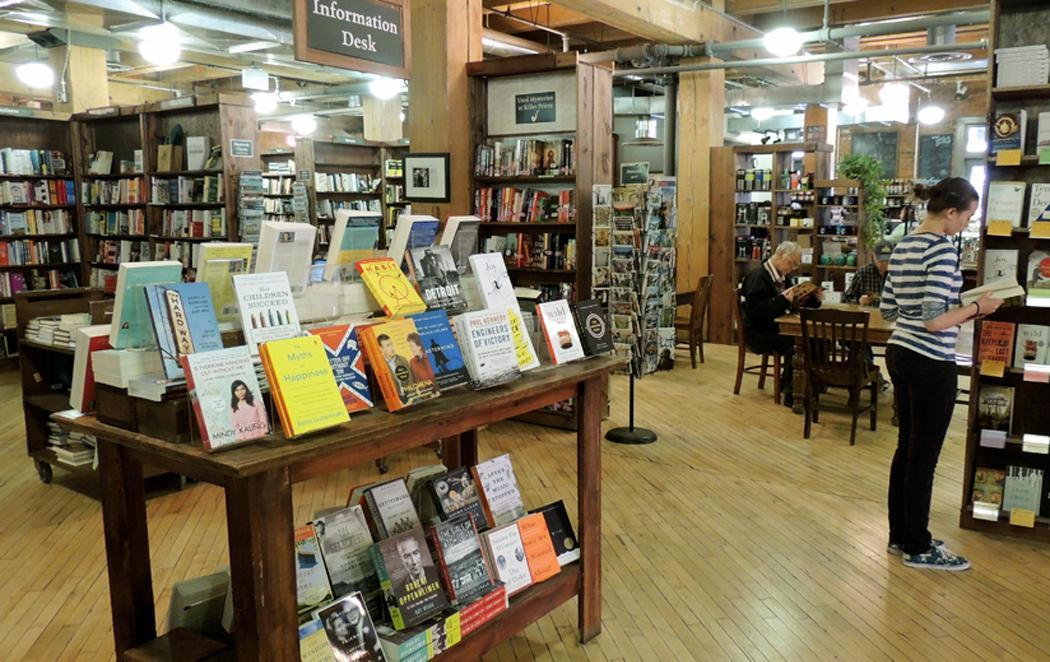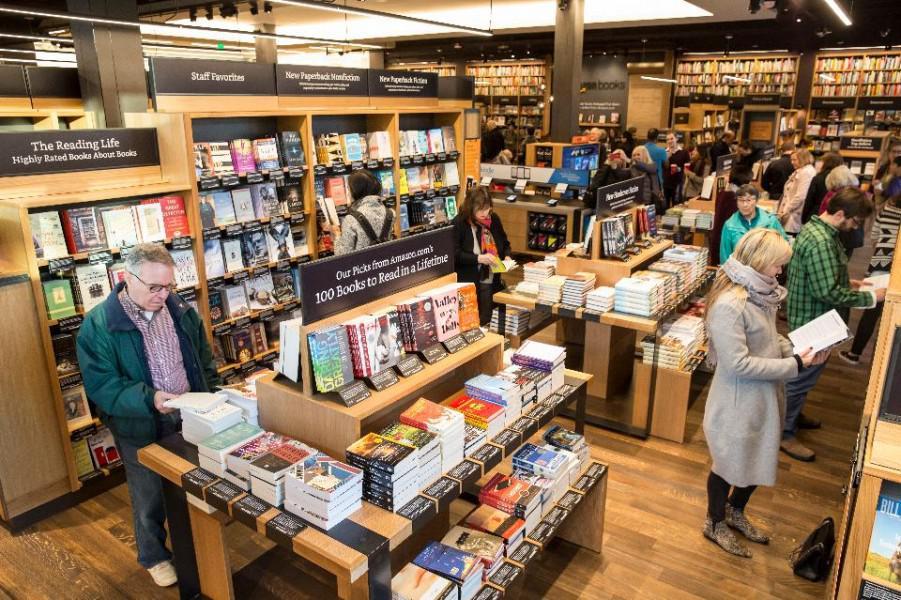The first image is the image on the left, the second image is the image on the right. For the images displayed, is the sentence "There are no more than 3 people in the image on the left." factually correct? Answer yes or no. Yes. 